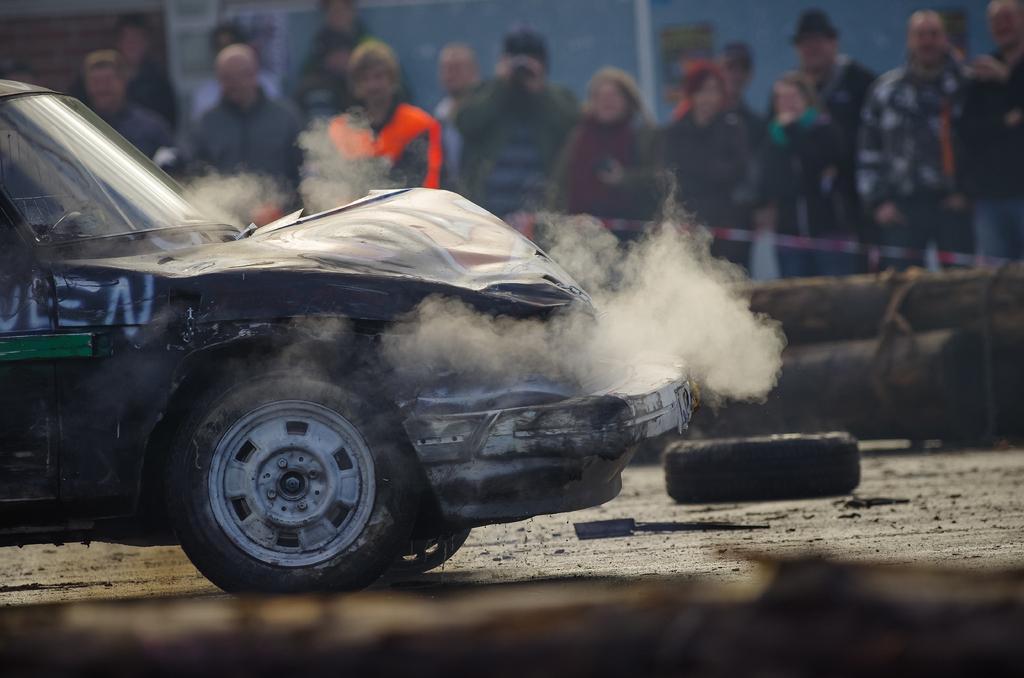Could you give a brief overview of what you see in this image? In this image I can see a damaged vehicle in the front and I can also see smoke and a wheel on the ground. In the background I can see number of people are standing and I can also see this image is little bit blurry. 